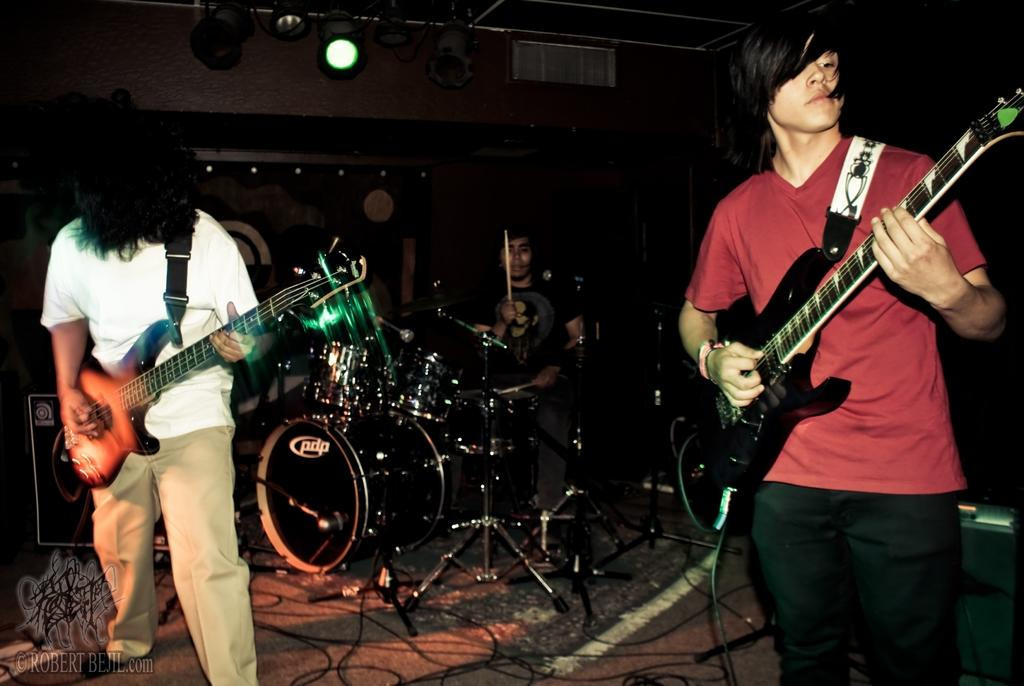What is the person holding in the image? The person is holding a book. Where is the person sitting in the image? The person is sitting on a bench. What type of letter is the person writing with a quill in the image? There is no letter or quill present in the image; the person is holding a book. 